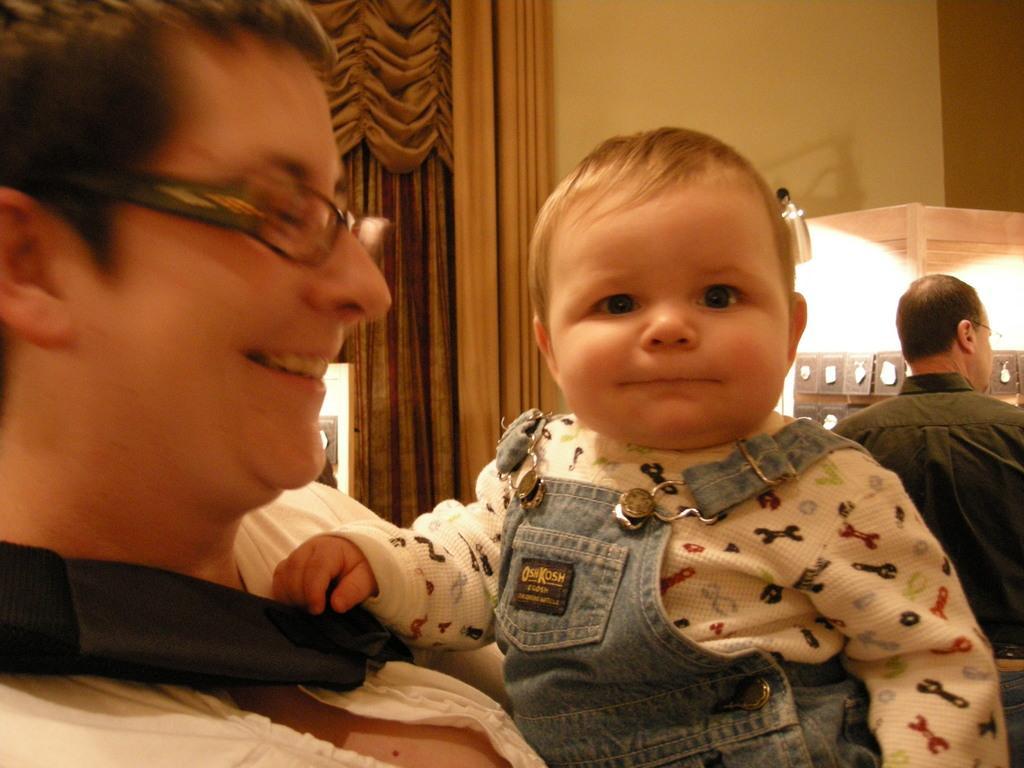Could you give a brief overview of what you see in this image? There is a person and a baby in the foreground area of the image, there are curtains, a person and some objects in the background. 